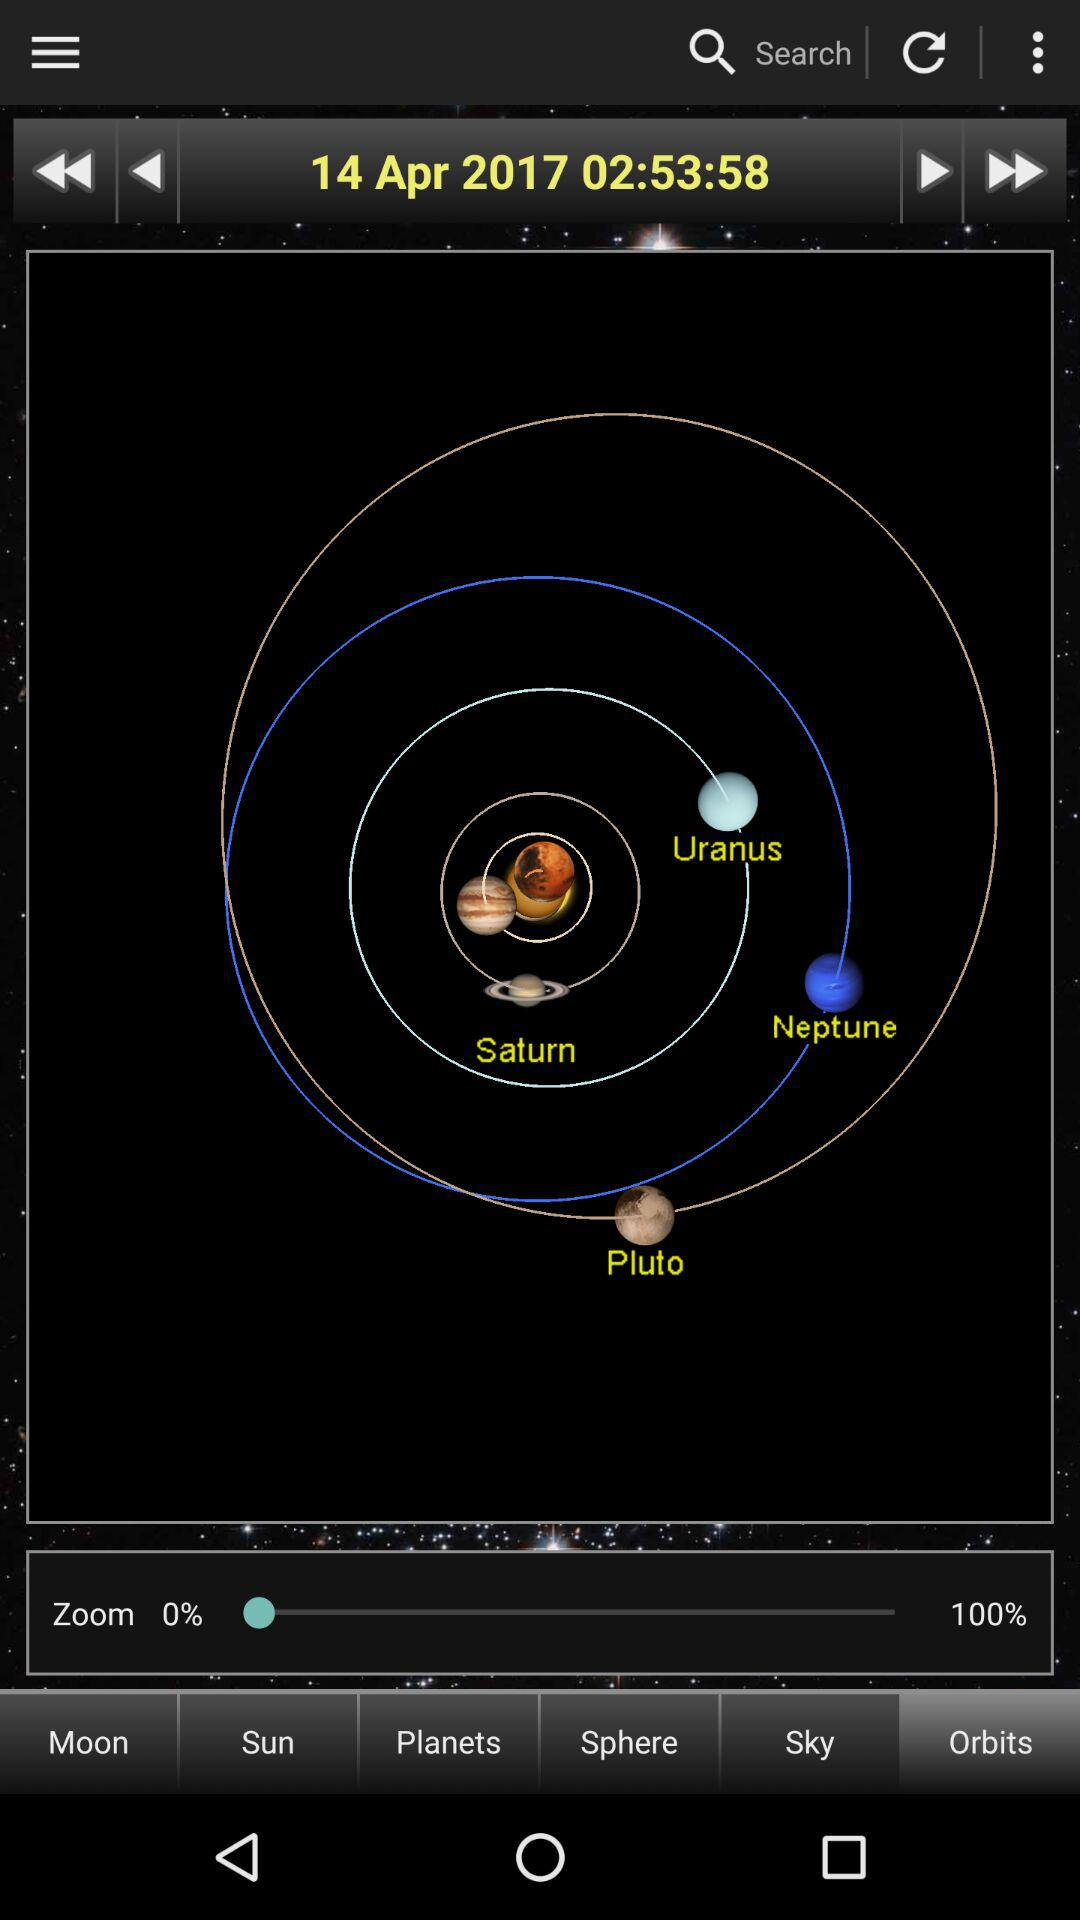What date is display on the screen? The date is April 14, 2017. 